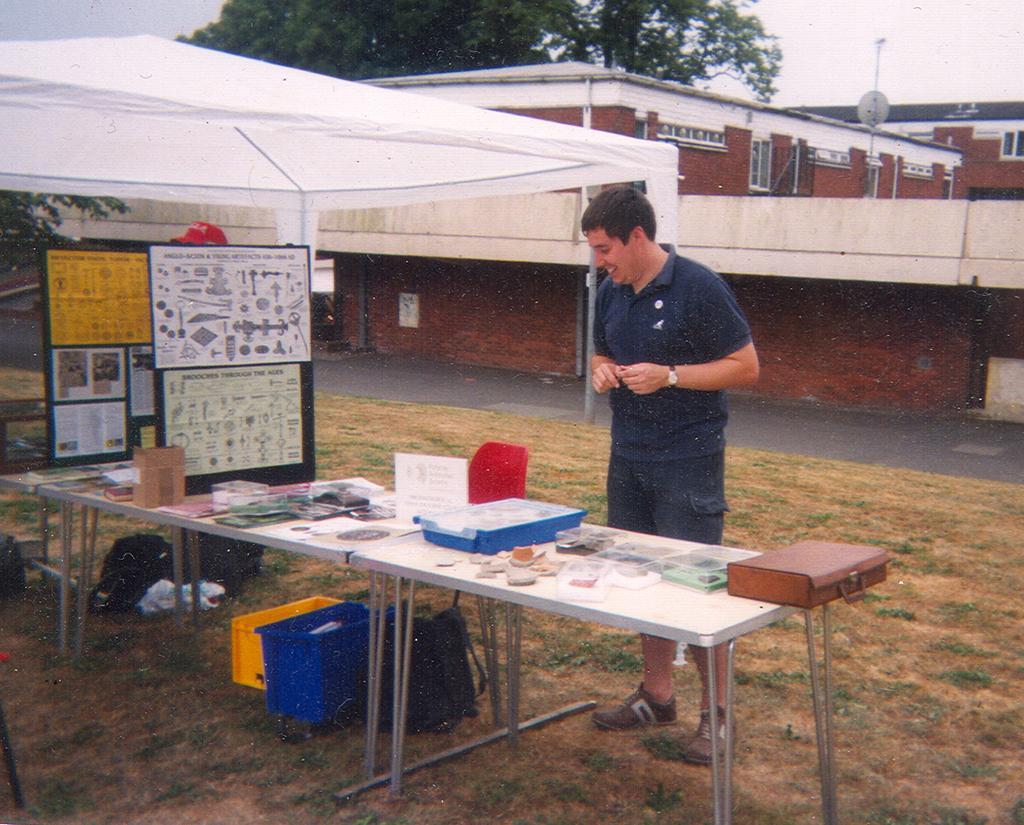Can you describe this image briefly? In the foreground of this image, there is man standing on the ground and there are tables and objects placed on the table in front of him. In the background, there is a white colored tent, trees building and the sky. 